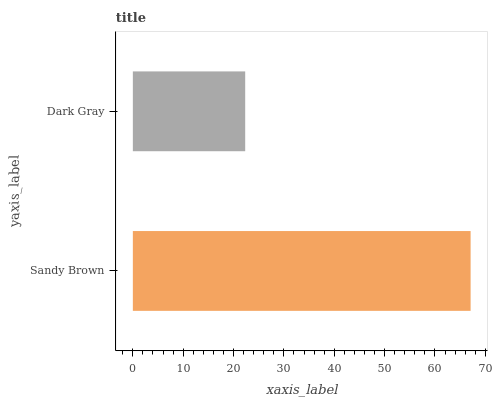Is Dark Gray the minimum?
Answer yes or no. Yes. Is Sandy Brown the maximum?
Answer yes or no. Yes. Is Dark Gray the maximum?
Answer yes or no. No. Is Sandy Brown greater than Dark Gray?
Answer yes or no. Yes. Is Dark Gray less than Sandy Brown?
Answer yes or no. Yes. Is Dark Gray greater than Sandy Brown?
Answer yes or no. No. Is Sandy Brown less than Dark Gray?
Answer yes or no. No. Is Sandy Brown the high median?
Answer yes or no. Yes. Is Dark Gray the low median?
Answer yes or no. Yes. Is Dark Gray the high median?
Answer yes or no. No. Is Sandy Brown the low median?
Answer yes or no. No. 